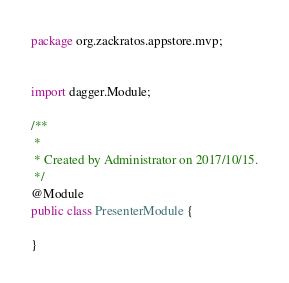<code> <loc_0><loc_0><loc_500><loc_500><_Java_>package org.zackratos.appstore.mvp;


import dagger.Module;

/**
 *
 * Created by Administrator on 2017/10/15.
 */
@Module
public class PresenterModule {

}
</code> 